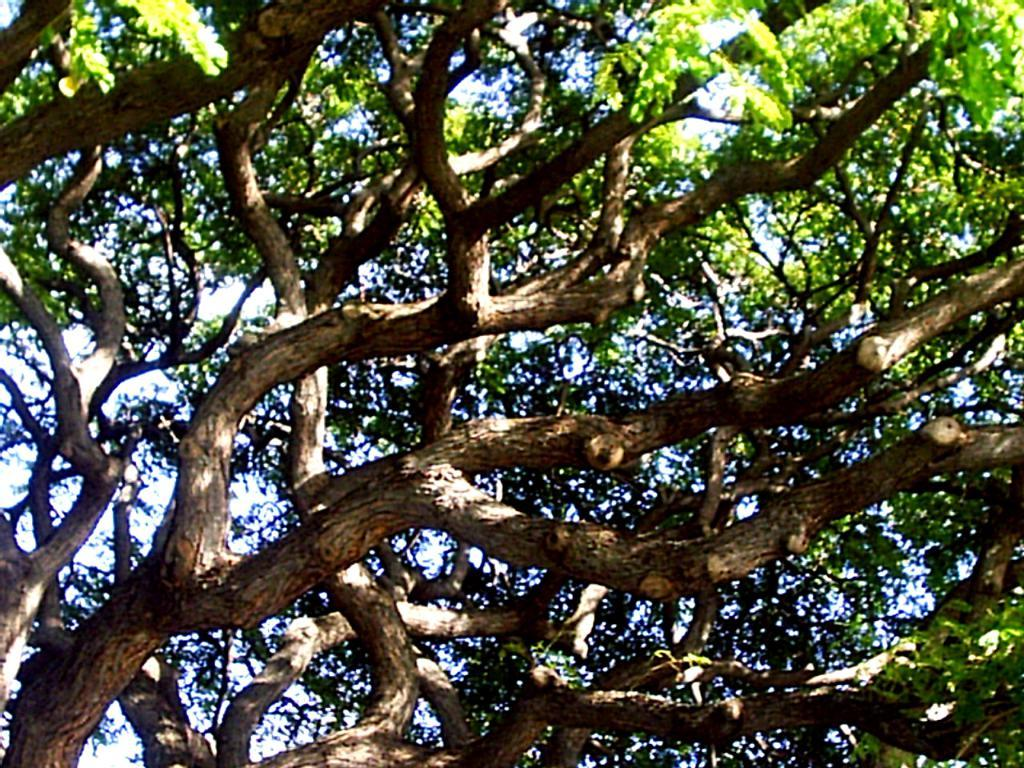What is the main subject of the picture? The main subject of the picture is a tree. Can you describe the tree in the image? The tree has branches. What can be seen in the background of the image? The sky is visible in the background of the image. How many horses are involved in the image? There are no horses present in the image; it features a tree with branches and a visible sky in the background. What season is depicted in the image? The provided facts do not mention any specific season or seasonal elements, so it cannot be determined from the image. 